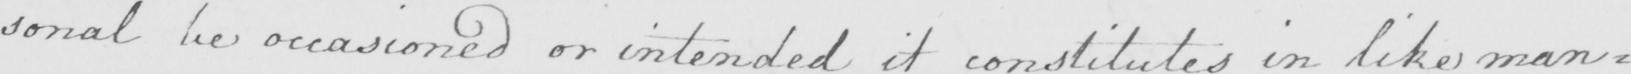What is written in this line of handwriting? : sonal be occasioned or intended it constitutes in like man : 